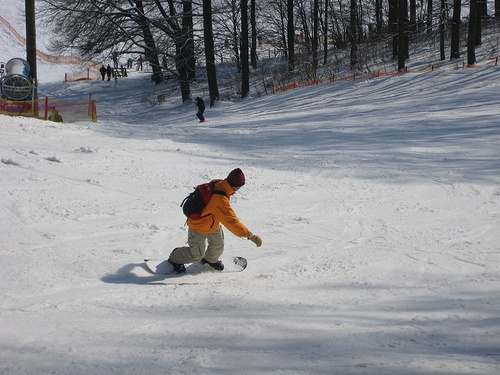Describe the objects in this image and their specific colors. I can see people in darkgray, black, gray, brown, and maroon tones, snowboard in darkgray, gray, lightgray, and black tones, backpack in darkgray, black, maroon, and gray tones, people in darkgray, black, gray, and darkblue tones, and people in darkgray, black, and gray tones in this image. 